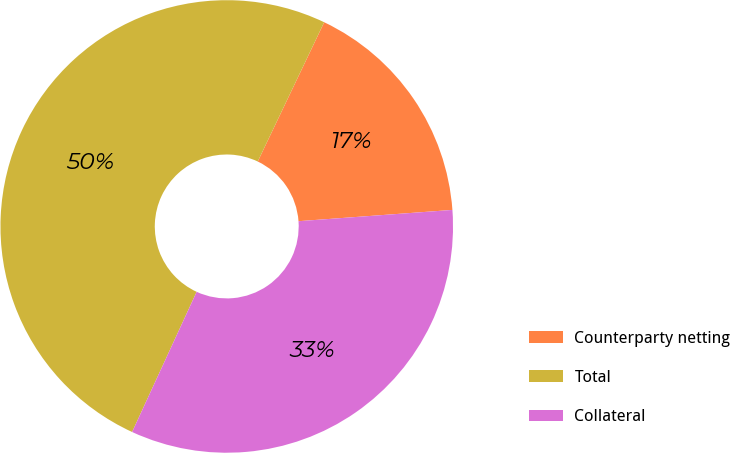Convert chart. <chart><loc_0><loc_0><loc_500><loc_500><pie_chart><fcel>Counterparty netting<fcel>Total<fcel>Collateral<nl><fcel>16.75%<fcel>50.22%<fcel>33.03%<nl></chart> 